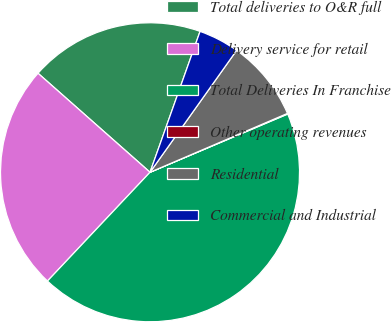Convert chart. <chart><loc_0><loc_0><loc_500><loc_500><pie_chart><fcel>Total deliveries to O&R full<fcel>Delivery service for retail<fcel>Total Deliveries In Franchise<fcel>Other operating revenues<fcel>Residential<fcel>Commercial and Industrial<nl><fcel>18.91%<fcel>24.49%<fcel>43.4%<fcel>0.07%<fcel>8.73%<fcel>4.4%<nl></chart> 